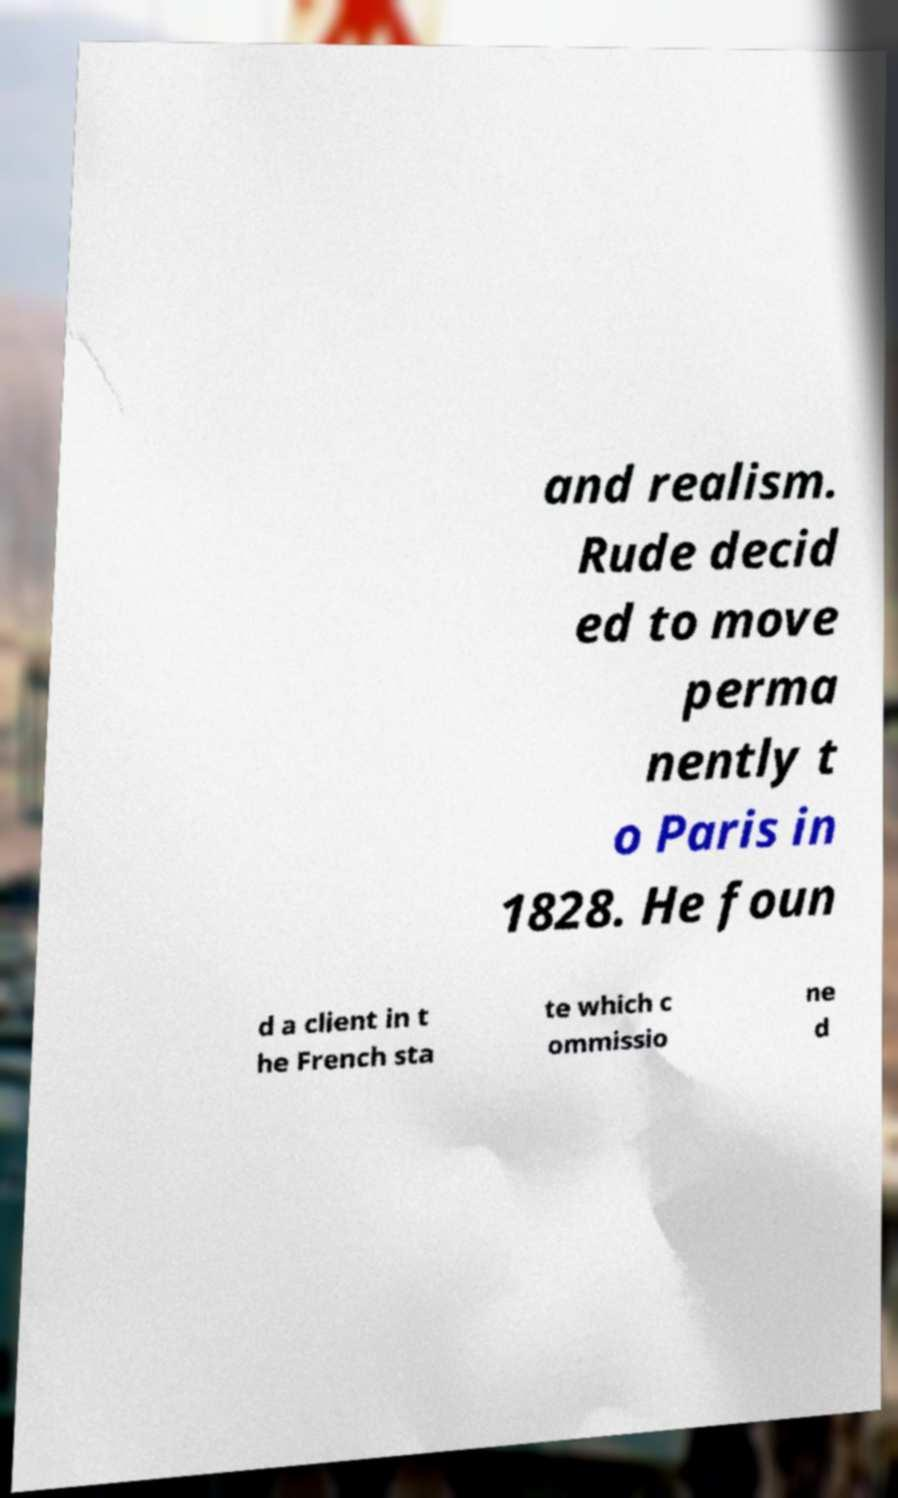Can you read and provide the text displayed in the image?This photo seems to have some interesting text. Can you extract and type it out for me? and realism. Rude decid ed to move perma nently t o Paris in 1828. He foun d a client in t he French sta te which c ommissio ne d 